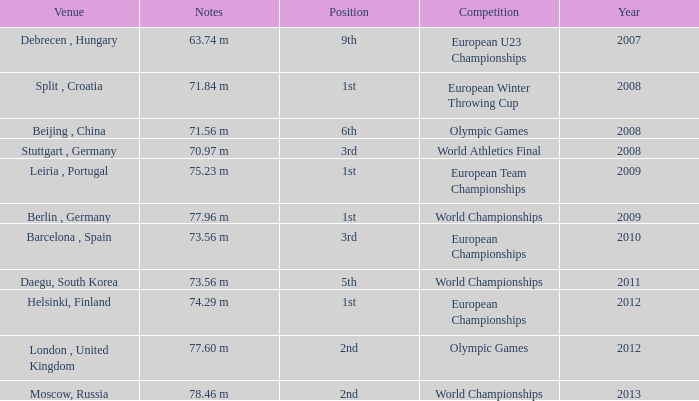What was the venue after 2012? Moscow, Russia. 